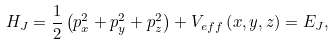Convert formula to latex. <formula><loc_0><loc_0><loc_500><loc_500>& H _ { J } = \frac { 1 } { 2 } \left ( p _ { x } ^ { 2 } + p _ { y } ^ { 2 } + p _ { z } ^ { 2 } \right ) + V _ { e f f } \left ( x , y , z \right ) = E _ { J } , &</formula> 